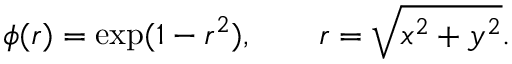<formula> <loc_0><loc_0><loc_500><loc_500>\phi ( r ) = \exp ( 1 - r ^ { 2 } ) , \quad r = \sqrt { x ^ { 2 } + y ^ { 2 } } .</formula> 